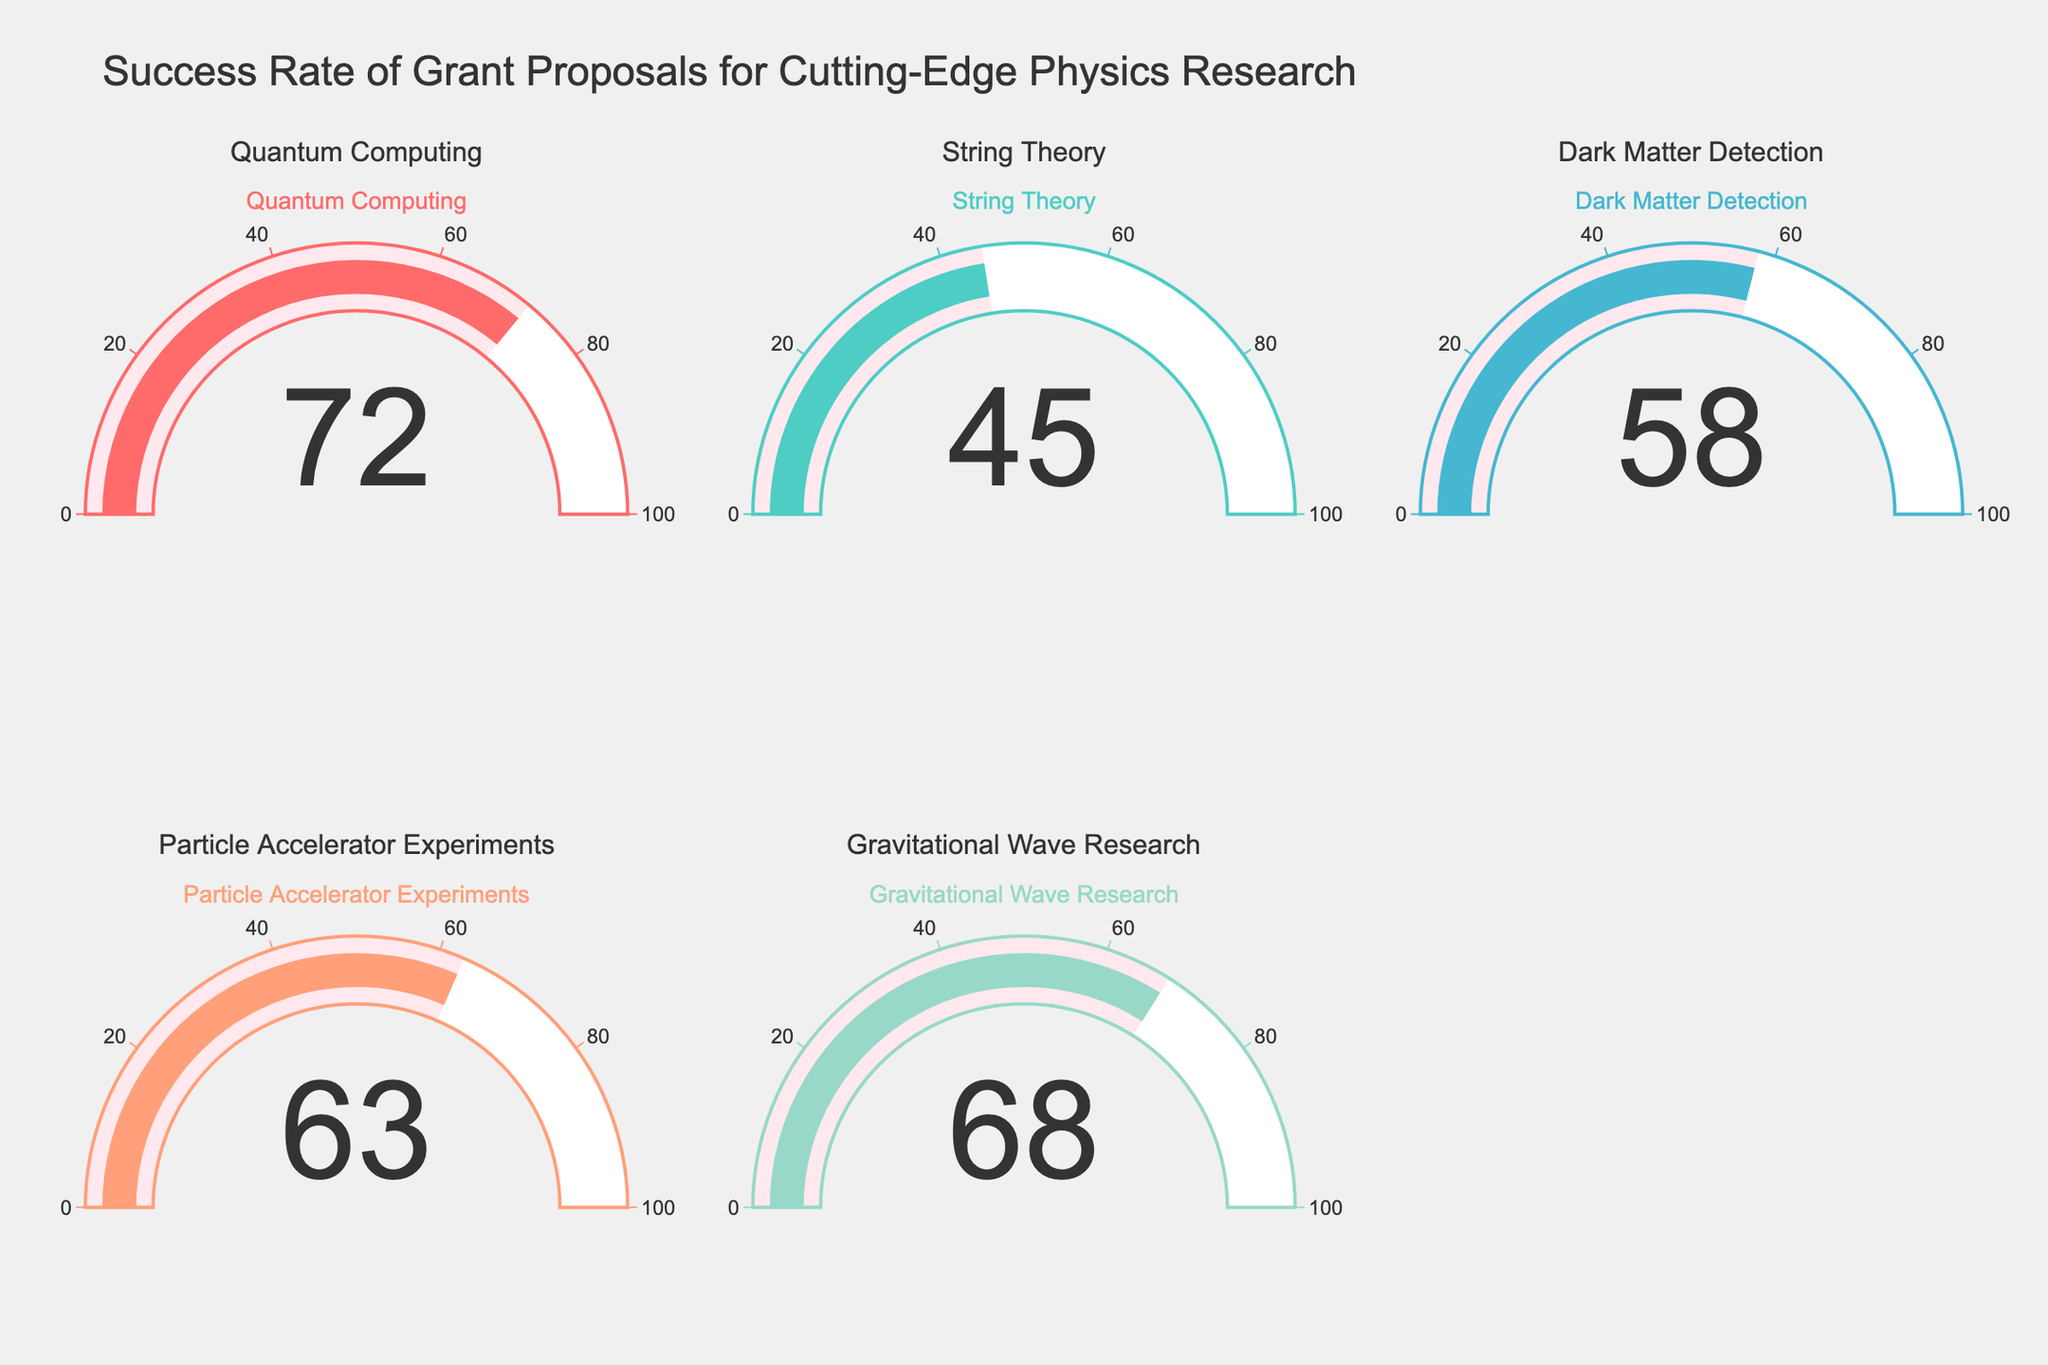What's the title of the figure? The figure's title is located at the top and serves as an overview of the data it presents. It reads "Success Rate of Grant Proposals for Cutting-Edge Physics Research".
Answer: Success Rate of Grant Proposals for Cutting-Edge Physics Research What is the success rate for Quantum Computing grant proposals? The number displayed on the right half of the gauge for Quantum Computing indicates the success rate of grant proposals in this category.
Answer: 72 Which category has the lowest success rate? By comparing all the gauges, the lowest value displayed corresponds to one category. The lowest value is 45, associated with String Theory.
Answer: String Theory What is the average success rate of all the categories combined? Add the success rates of all categories and divide by the number of categories: (72 + 45 + 58 + 63 + 68) / 5 = 306 / 5 = 61.2.
Answer: 61.2 How many categories have a success rate above 60? Count the categories where the value on the gauge exceeds 60. Quantum Computing (72), Particle Accelerator Experiments (63), and Gravitational Wave Research (68) each meet this criterion.
Answer: 3 Is the success rate for Dark Matter Detection higher or lower than for Particle Accelerator Experiments? Compare the gauge values of Dark Matter Detection and Particle Accelerator Experiments directly. Dark Matter Detection shows 58, while Particle Accelerator Experiments shows 63.
Answer: Lower What's the difference in success rates between the category with the highest success rate and the category with the lowest success rate? Subtract the lowest success rate value from the highest: 72 (Quantum Computing) - 45 (String Theory) = 27.
Answer: 27 What's the median success rate among these categories? First list the success rates in ascending order: 45, 58, 63, 68, 72. The median value, being the middle one in this ordered list, is 63.
Answer: 63 Which categories fall within the success rate range of 50 to 70? Identify categories that have their success rates displayed within this range. These include Dark Matter Detection (58), Particle Accelerator Experiments (63), and Gravitational Wave Research (68).
Answer: Dark Matter Detection, Particle Accelerator Experiments, Gravitational Wave Research 